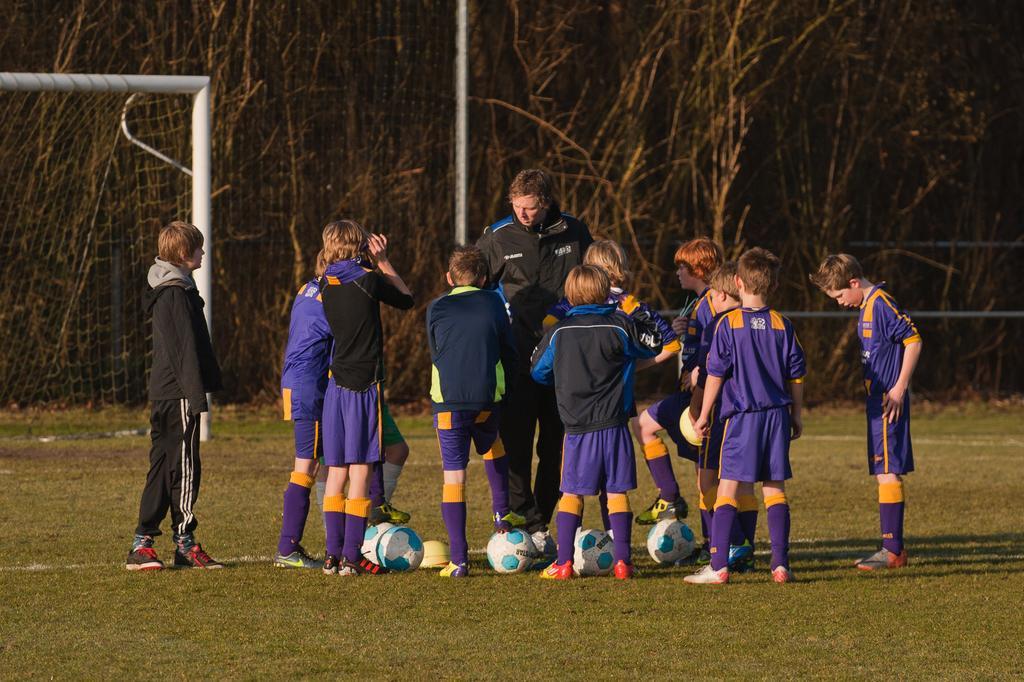Can you describe this image briefly? This is a picture taken in the outdoor, there are group of kids standing on a ground on the ground there are balls. Behind the people there are trees and a net. 